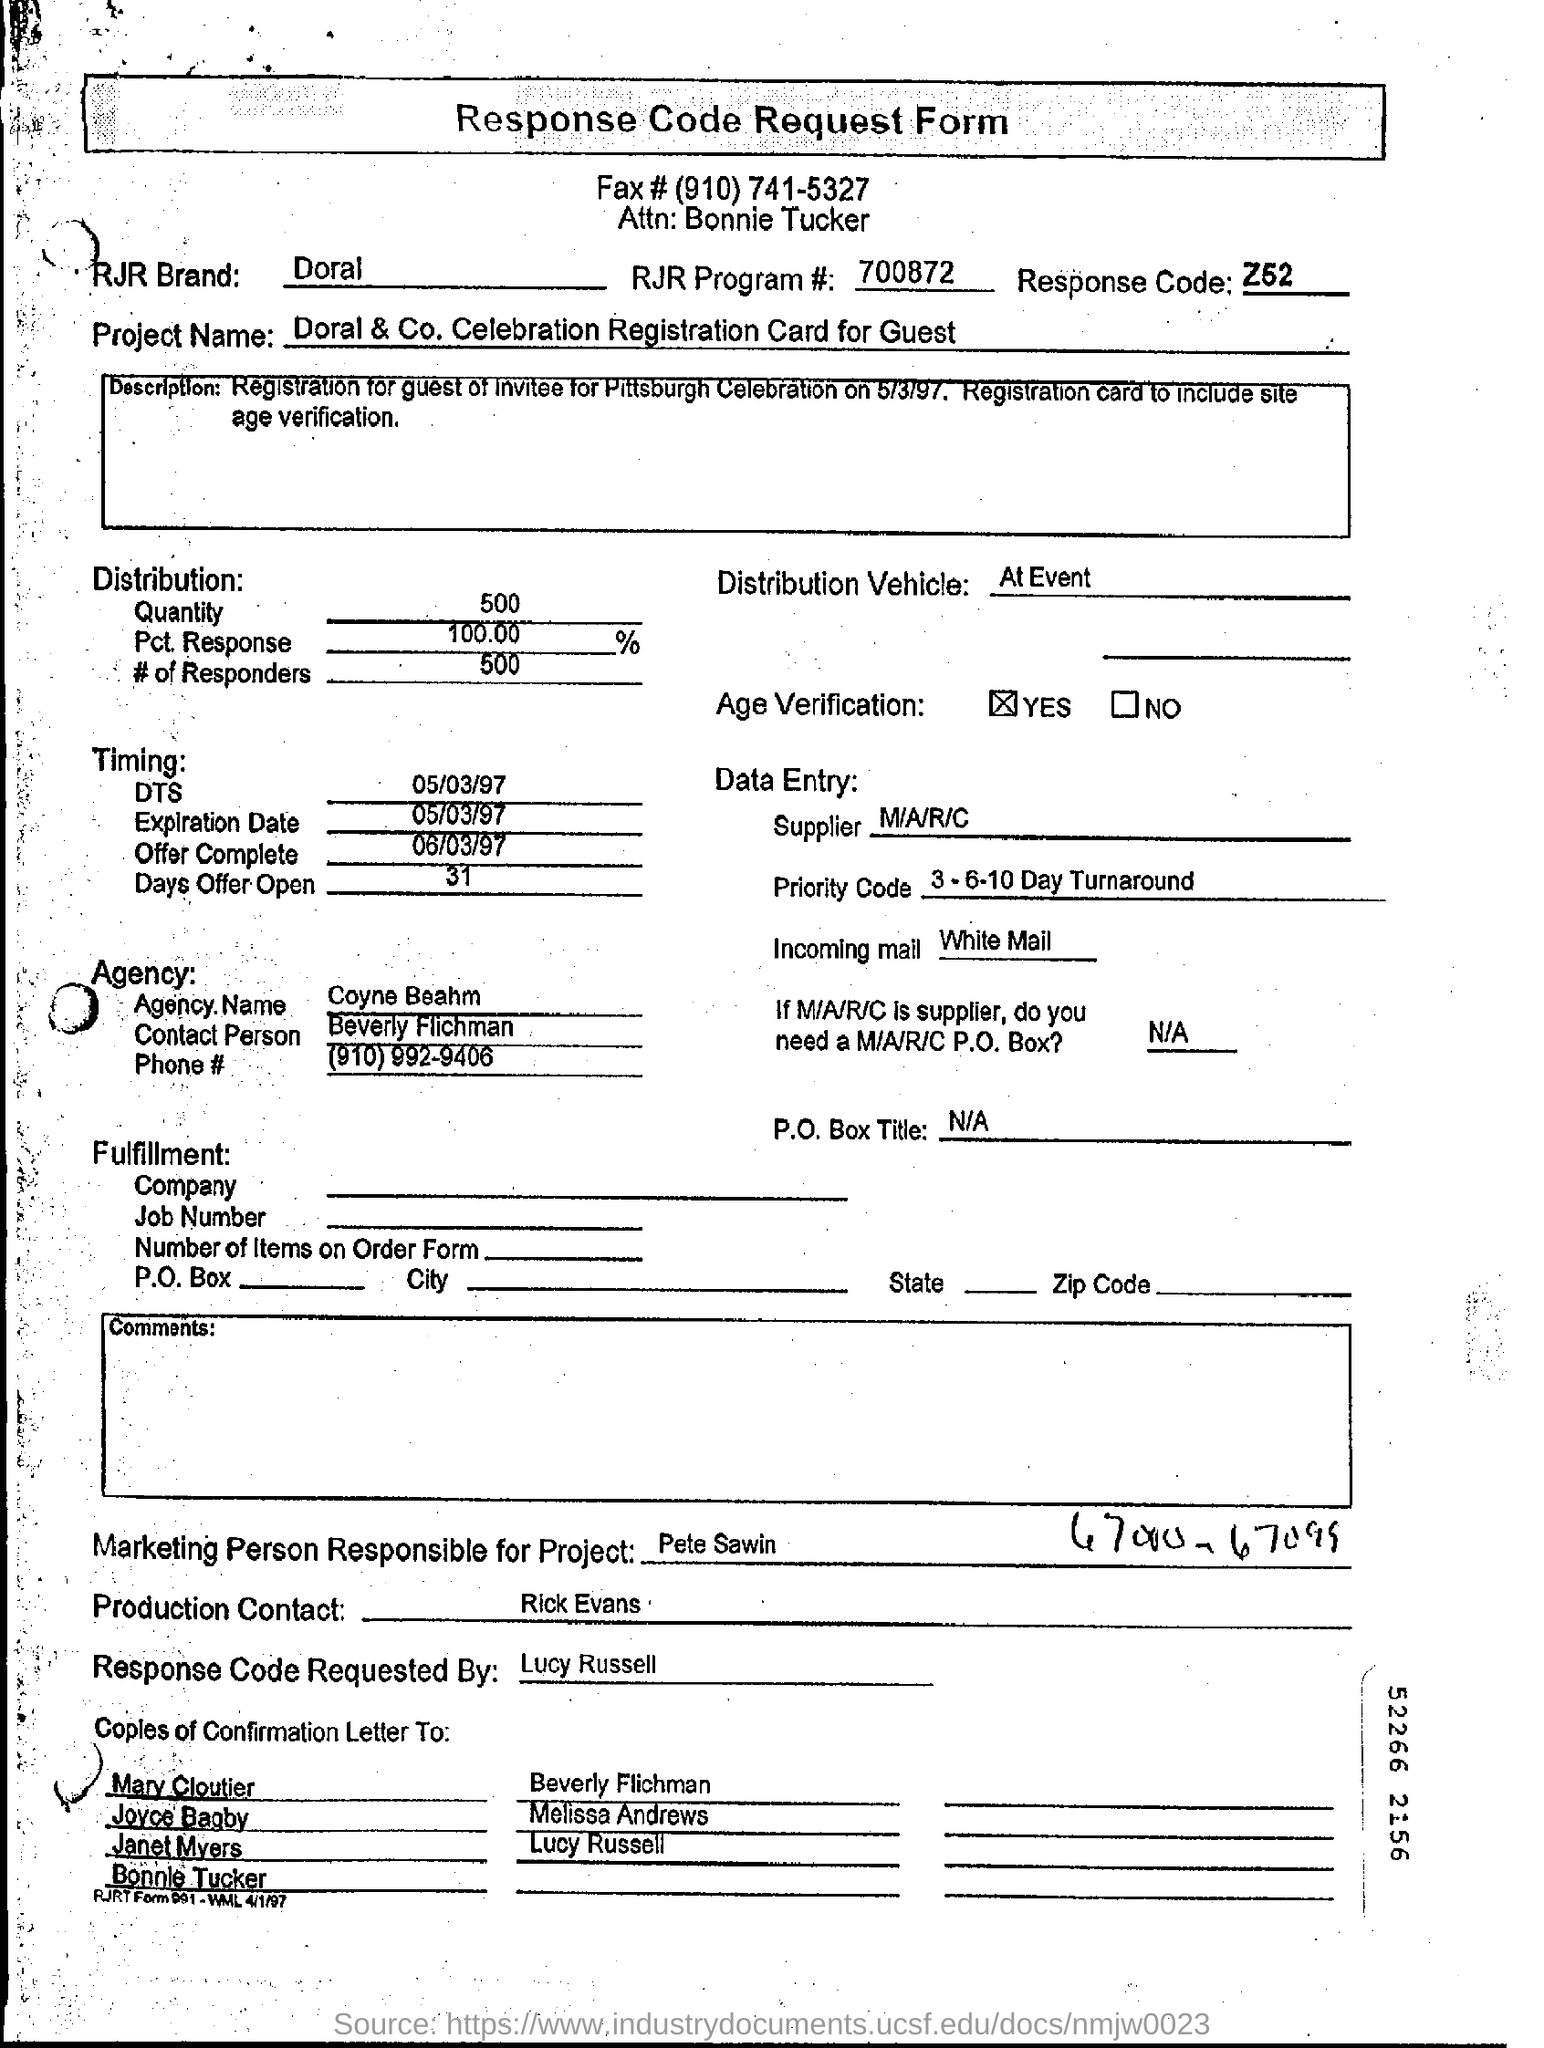Highlight a few significant elements in this photo. The response code mentioned on the form is Z52. The distribution of the quantity was 500... The offer is set to expire on May 3, 1997. The offer is expected to be completed on March 6, 1997. The marketing person responsible for the project is Pete Sawin. 